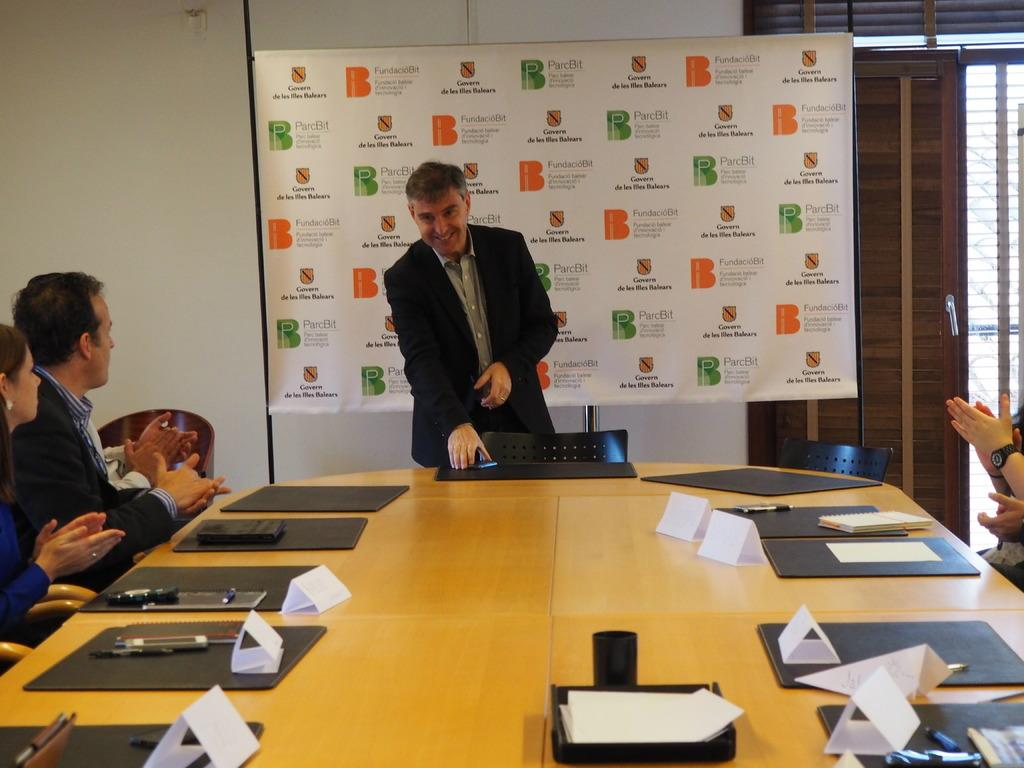How many people are in the image? There are persons in the image, but the exact number cannot be determined from the provided facts. What type of furniture is present in the image? There are chairs in the image. What other objects can be seen in the image besides chairs? There are other objects in the image, but their specific nature cannot be determined from the provided facts. What can be seen in the background of the image? In the background of the image, there is a wall, a banner, a door, a glass window, and other objects. How does the person in the image control the temperature of the room? There is no information about temperature control in the image, so it cannot be determined how the person controls the temperature of the room. 